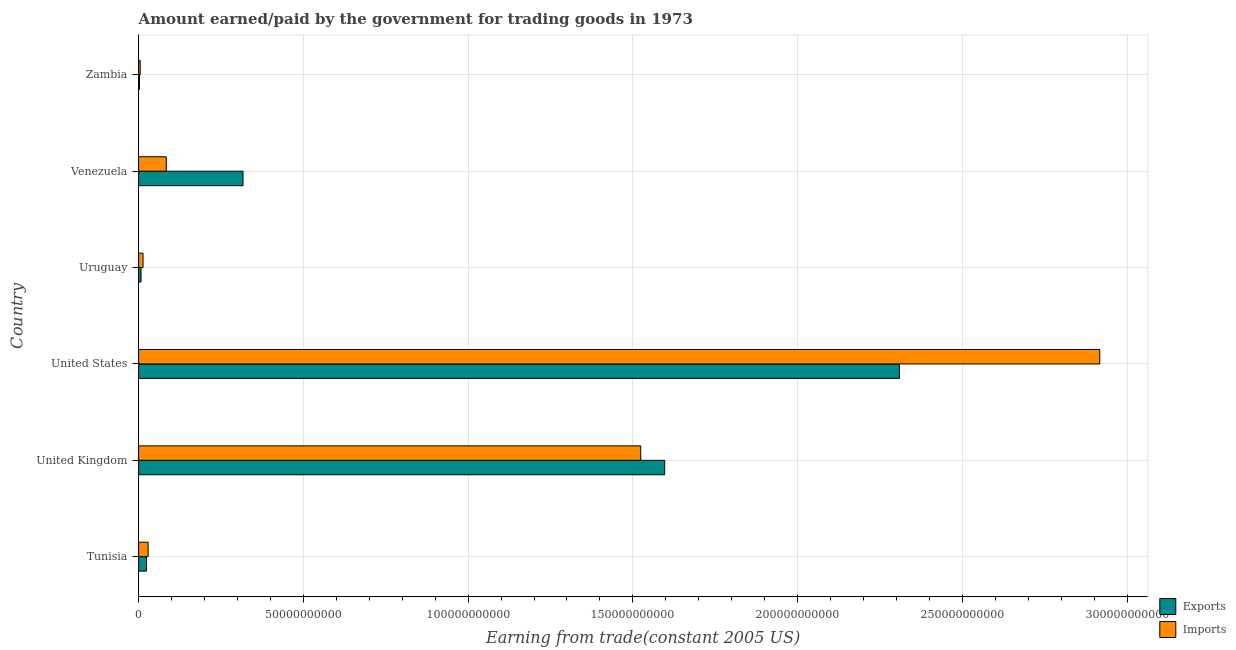Are the number of bars on each tick of the Y-axis equal?
Offer a terse response. Yes. What is the label of the 5th group of bars from the top?
Provide a succinct answer. United Kingdom. In how many cases, is the number of bars for a given country not equal to the number of legend labels?
Keep it short and to the point. 0. What is the amount paid for imports in United States?
Your response must be concise. 2.92e+11. Across all countries, what is the maximum amount earned from exports?
Your answer should be compact. 2.31e+11. Across all countries, what is the minimum amount paid for imports?
Your answer should be very brief. 4.80e+08. In which country was the amount earned from exports maximum?
Offer a very short reply. United States. In which country was the amount earned from exports minimum?
Offer a very short reply. Zambia. What is the total amount paid for imports in the graph?
Your answer should be compact. 4.57e+11. What is the difference between the amount earned from exports in United States and that in Zambia?
Offer a terse response. 2.31e+11. What is the difference between the amount paid for imports in Uruguay and the amount earned from exports in Venezuela?
Your answer should be very brief. -3.03e+1. What is the average amount paid for imports per country?
Make the answer very short. 7.62e+1. What is the difference between the amount earned from exports and amount paid for imports in United States?
Ensure brevity in your answer.  -6.08e+1. What is the ratio of the amount earned from exports in Tunisia to that in Uruguay?
Provide a succinct answer. 3.25. What is the difference between the highest and the second highest amount paid for imports?
Offer a terse response. 1.39e+11. What is the difference between the highest and the lowest amount earned from exports?
Provide a succinct answer. 2.31e+11. In how many countries, is the amount paid for imports greater than the average amount paid for imports taken over all countries?
Ensure brevity in your answer.  2. What does the 1st bar from the top in Tunisia represents?
Offer a terse response. Imports. What does the 1st bar from the bottom in Zambia represents?
Offer a terse response. Exports. How many bars are there?
Provide a succinct answer. 12. How many countries are there in the graph?
Ensure brevity in your answer.  6. What is the difference between two consecutive major ticks on the X-axis?
Give a very brief answer. 5.00e+1. Are the values on the major ticks of X-axis written in scientific E-notation?
Make the answer very short. No. How many legend labels are there?
Your answer should be compact. 2. What is the title of the graph?
Provide a short and direct response. Amount earned/paid by the government for trading goods in 1973. Does "Female population" appear as one of the legend labels in the graph?
Ensure brevity in your answer.  No. What is the label or title of the X-axis?
Your answer should be very brief. Earning from trade(constant 2005 US). What is the label or title of the Y-axis?
Keep it short and to the point. Country. What is the Earning from trade(constant 2005 US) of Exports in Tunisia?
Ensure brevity in your answer.  2.40e+09. What is the Earning from trade(constant 2005 US) of Imports in Tunisia?
Give a very brief answer. 2.89e+09. What is the Earning from trade(constant 2005 US) of Exports in United Kingdom?
Ensure brevity in your answer.  1.60e+11. What is the Earning from trade(constant 2005 US) in Imports in United Kingdom?
Offer a terse response. 1.52e+11. What is the Earning from trade(constant 2005 US) in Exports in United States?
Offer a terse response. 2.31e+11. What is the Earning from trade(constant 2005 US) of Imports in United States?
Your answer should be compact. 2.92e+11. What is the Earning from trade(constant 2005 US) in Exports in Uruguay?
Offer a very short reply. 7.36e+08. What is the Earning from trade(constant 2005 US) of Imports in Uruguay?
Provide a short and direct response. 1.34e+09. What is the Earning from trade(constant 2005 US) of Exports in Venezuela?
Offer a terse response. 3.17e+1. What is the Earning from trade(constant 2005 US) in Imports in Venezuela?
Keep it short and to the point. 8.39e+09. What is the Earning from trade(constant 2005 US) in Exports in Zambia?
Your answer should be compact. 2.44e+08. What is the Earning from trade(constant 2005 US) of Imports in Zambia?
Provide a short and direct response. 4.80e+08. Across all countries, what is the maximum Earning from trade(constant 2005 US) of Exports?
Give a very brief answer. 2.31e+11. Across all countries, what is the maximum Earning from trade(constant 2005 US) of Imports?
Provide a short and direct response. 2.92e+11. Across all countries, what is the minimum Earning from trade(constant 2005 US) of Exports?
Your answer should be compact. 2.44e+08. Across all countries, what is the minimum Earning from trade(constant 2005 US) of Imports?
Offer a very short reply. 4.80e+08. What is the total Earning from trade(constant 2005 US) of Exports in the graph?
Make the answer very short. 4.26e+11. What is the total Earning from trade(constant 2005 US) of Imports in the graph?
Provide a succinct answer. 4.57e+11. What is the difference between the Earning from trade(constant 2005 US) of Exports in Tunisia and that in United Kingdom?
Your response must be concise. -1.57e+11. What is the difference between the Earning from trade(constant 2005 US) in Imports in Tunisia and that in United Kingdom?
Your answer should be compact. -1.49e+11. What is the difference between the Earning from trade(constant 2005 US) in Exports in Tunisia and that in United States?
Your response must be concise. -2.29e+11. What is the difference between the Earning from trade(constant 2005 US) of Imports in Tunisia and that in United States?
Your answer should be compact. -2.89e+11. What is the difference between the Earning from trade(constant 2005 US) of Exports in Tunisia and that in Uruguay?
Ensure brevity in your answer.  1.66e+09. What is the difference between the Earning from trade(constant 2005 US) in Imports in Tunisia and that in Uruguay?
Your response must be concise. 1.55e+09. What is the difference between the Earning from trade(constant 2005 US) in Exports in Tunisia and that in Venezuela?
Offer a very short reply. -2.93e+1. What is the difference between the Earning from trade(constant 2005 US) of Imports in Tunisia and that in Venezuela?
Provide a short and direct response. -5.50e+09. What is the difference between the Earning from trade(constant 2005 US) in Exports in Tunisia and that in Zambia?
Ensure brevity in your answer.  2.15e+09. What is the difference between the Earning from trade(constant 2005 US) in Imports in Tunisia and that in Zambia?
Your answer should be compact. 2.41e+09. What is the difference between the Earning from trade(constant 2005 US) in Exports in United Kingdom and that in United States?
Your response must be concise. -7.12e+1. What is the difference between the Earning from trade(constant 2005 US) of Imports in United Kingdom and that in United States?
Ensure brevity in your answer.  -1.39e+11. What is the difference between the Earning from trade(constant 2005 US) of Exports in United Kingdom and that in Uruguay?
Your response must be concise. 1.59e+11. What is the difference between the Earning from trade(constant 2005 US) of Imports in United Kingdom and that in Uruguay?
Offer a terse response. 1.51e+11. What is the difference between the Earning from trade(constant 2005 US) in Exports in United Kingdom and that in Venezuela?
Make the answer very short. 1.28e+11. What is the difference between the Earning from trade(constant 2005 US) of Imports in United Kingdom and that in Venezuela?
Your response must be concise. 1.44e+11. What is the difference between the Earning from trade(constant 2005 US) of Exports in United Kingdom and that in Zambia?
Your response must be concise. 1.59e+11. What is the difference between the Earning from trade(constant 2005 US) in Imports in United Kingdom and that in Zambia?
Make the answer very short. 1.52e+11. What is the difference between the Earning from trade(constant 2005 US) of Exports in United States and that in Uruguay?
Ensure brevity in your answer.  2.30e+11. What is the difference between the Earning from trade(constant 2005 US) in Imports in United States and that in Uruguay?
Your answer should be compact. 2.90e+11. What is the difference between the Earning from trade(constant 2005 US) of Exports in United States and that in Venezuela?
Make the answer very short. 1.99e+11. What is the difference between the Earning from trade(constant 2005 US) of Imports in United States and that in Venezuela?
Your response must be concise. 2.83e+11. What is the difference between the Earning from trade(constant 2005 US) of Exports in United States and that in Zambia?
Keep it short and to the point. 2.31e+11. What is the difference between the Earning from trade(constant 2005 US) in Imports in United States and that in Zambia?
Your response must be concise. 2.91e+11. What is the difference between the Earning from trade(constant 2005 US) of Exports in Uruguay and that in Venezuela?
Your response must be concise. -3.10e+1. What is the difference between the Earning from trade(constant 2005 US) of Imports in Uruguay and that in Venezuela?
Your answer should be compact. -7.05e+09. What is the difference between the Earning from trade(constant 2005 US) of Exports in Uruguay and that in Zambia?
Provide a short and direct response. 4.93e+08. What is the difference between the Earning from trade(constant 2005 US) of Imports in Uruguay and that in Zambia?
Provide a succinct answer. 8.60e+08. What is the difference between the Earning from trade(constant 2005 US) of Exports in Venezuela and that in Zambia?
Ensure brevity in your answer.  3.14e+1. What is the difference between the Earning from trade(constant 2005 US) in Imports in Venezuela and that in Zambia?
Your response must be concise. 7.91e+09. What is the difference between the Earning from trade(constant 2005 US) of Exports in Tunisia and the Earning from trade(constant 2005 US) of Imports in United Kingdom?
Offer a very short reply. -1.50e+11. What is the difference between the Earning from trade(constant 2005 US) of Exports in Tunisia and the Earning from trade(constant 2005 US) of Imports in United States?
Offer a terse response. -2.89e+11. What is the difference between the Earning from trade(constant 2005 US) in Exports in Tunisia and the Earning from trade(constant 2005 US) in Imports in Uruguay?
Your answer should be very brief. 1.06e+09. What is the difference between the Earning from trade(constant 2005 US) of Exports in Tunisia and the Earning from trade(constant 2005 US) of Imports in Venezuela?
Offer a very short reply. -6.00e+09. What is the difference between the Earning from trade(constant 2005 US) of Exports in Tunisia and the Earning from trade(constant 2005 US) of Imports in Zambia?
Make the answer very short. 1.92e+09. What is the difference between the Earning from trade(constant 2005 US) in Exports in United Kingdom and the Earning from trade(constant 2005 US) in Imports in United States?
Ensure brevity in your answer.  -1.32e+11. What is the difference between the Earning from trade(constant 2005 US) of Exports in United Kingdom and the Earning from trade(constant 2005 US) of Imports in Uruguay?
Ensure brevity in your answer.  1.58e+11. What is the difference between the Earning from trade(constant 2005 US) in Exports in United Kingdom and the Earning from trade(constant 2005 US) in Imports in Venezuela?
Give a very brief answer. 1.51e+11. What is the difference between the Earning from trade(constant 2005 US) of Exports in United Kingdom and the Earning from trade(constant 2005 US) of Imports in Zambia?
Give a very brief answer. 1.59e+11. What is the difference between the Earning from trade(constant 2005 US) in Exports in United States and the Earning from trade(constant 2005 US) in Imports in Uruguay?
Provide a succinct answer. 2.30e+11. What is the difference between the Earning from trade(constant 2005 US) in Exports in United States and the Earning from trade(constant 2005 US) in Imports in Venezuela?
Give a very brief answer. 2.23e+11. What is the difference between the Earning from trade(constant 2005 US) of Exports in United States and the Earning from trade(constant 2005 US) of Imports in Zambia?
Give a very brief answer. 2.30e+11. What is the difference between the Earning from trade(constant 2005 US) in Exports in Uruguay and the Earning from trade(constant 2005 US) in Imports in Venezuela?
Your answer should be compact. -7.66e+09. What is the difference between the Earning from trade(constant 2005 US) in Exports in Uruguay and the Earning from trade(constant 2005 US) in Imports in Zambia?
Give a very brief answer. 2.56e+08. What is the difference between the Earning from trade(constant 2005 US) of Exports in Venezuela and the Earning from trade(constant 2005 US) of Imports in Zambia?
Your response must be concise. 3.12e+1. What is the average Earning from trade(constant 2005 US) in Exports per country?
Ensure brevity in your answer.  7.09e+1. What is the average Earning from trade(constant 2005 US) in Imports per country?
Give a very brief answer. 7.62e+1. What is the difference between the Earning from trade(constant 2005 US) in Exports and Earning from trade(constant 2005 US) in Imports in Tunisia?
Offer a very short reply. -4.94e+08. What is the difference between the Earning from trade(constant 2005 US) of Exports and Earning from trade(constant 2005 US) of Imports in United Kingdom?
Make the answer very short. 7.27e+09. What is the difference between the Earning from trade(constant 2005 US) in Exports and Earning from trade(constant 2005 US) in Imports in United States?
Keep it short and to the point. -6.08e+1. What is the difference between the Earning from trade(constant 2005 US) in Exports and Earning from trade(constant 2005 US) in Imports in Uruguay?
Your response must be concise. -6.03e+08. What is the difference between the Earning from trade(constant 2005 US) of Exports and Earning from trade(constant 2005 US) of Imports in Venezuela?
Offer a very short reply. 2.33e+1. What is the difference between the Earning from trade(constant 2005 US) of Exports and Earning from trade(constant 2005 US) of Imports in Zambia?
Give a very brief answer. -2.36e+08. What is the ratio of the Earning from trade(constant 2005 US) of Exports in Tunisia to that in United Kingdom?
Give a very brief answer. 0.01. What is the ratio of the Earning from trade(constant 2005 US) of Imports in Tunisia to that in United Kingdom?
Keep it short and to the point. 0.02. What is the ratio of the Earning from trade(constant 2005 US) of Exports in Tunisia to that in United States?
Offer a terse response. 0.01. What is the ratio of the Earning from trade(constant 2005 US) in Imports in Tunisia to that in United States?
Give a very brief answer. 0.01. What is the ratio of the Earning from trade(constant 2005 US) of Exports in Tunisia to that in Uruguay?
Offer a very short reply. 3.25. What is the ratio of the Earning from trade(constant 2005 US) of Imports in Tunisia to that in Uruguay?
Provide a short and direct response. 2.16. What is the ratio of the Earning from trade(constant 2005 US) of Exports in Tunisia to that in Venezuela?
Keep it short and to the point. 0.08. What is the ratio of the Earning from trade(constant 2005 US) in Imports in Tunisia to that in Venezuela?
Your answer should be very brief. 0.34. What is the ratio of the Earning from trade(constant 2005 US) in Exports in Tunisia to that in Zambia?
Your answer should be very brief. 9.84. What is the ratio of the Earning from trade(constant 2005 US) in Imports in Tunisia to that in Zambia?
Provide a succinct answer. 6.02. What is the ratio of the Earning from trade(constant 2005 US) in Exports in United Kingdom to that in United States?
Give a very brief answer. 0.69. What is the ratio of the Earning from trade(constant 2005 US) of Imports in United Kingdom to that in United States?
Provide a succinct answer. 0.52. What is the ratio of the Earning from trade(constant 2005 US) in Exports in United Kingdom to that in Uruguay?
Provide a succinct answer. 216.87. What is the ratio of the Earning from trade(constant 2005 US) in Imports in United Kingdom to that in Uruguay?
Make the answer very short. 113.75. What is the ratio of the Earning from trade(constant 2005 US) in Exports in United Kingdom to that in Venezuela?
Provide a succinct answer. 5.04. What is the ratio of the Earning from trade(constant 2005 US) of Imports in United Kingdom to that in Venezuela?
Keep it short and to the point. 18.16. What is the ratio of the Earning from trade(constant 2005 US) in Exports in United Kingdom to that in Zambia?
Provide a succinct answer. 655.49. What is the ratio of the Earning from trade(constant 2005 US) in Imports in United Kingdom to that in Zambia?
Ensure brevity in your answer.  317.45. What is the ratio of the Earning from trade(constant 2005 US) of Exports in United States to that in Uruguay?
Give a very brief answer. 313.66. What is the ratio of the Earning from trade(constant 2005 US) in Imports in United States to that in Uruguay?
Give a very brief answer. 217.74. What is the ratio of the Earning from trade(constant 2005 US) in Exports in United States to that in Venezuela?
Make the answer very short. 7.29. What is the ratio of the Earning from trade(constant 2005 US) of Imports in United States to that in Venezuela?
Offer a very short reply. 34.76. What is the ratio of the Earning from trade(constant 2005 US) of Exports in United States to that in Zambia?
Ensure brevity in your answer.  948.02. What is the ratio of the Earning from trade(constant 2005 US) of Imports in United States to that in Zambia?
Offer a very short reply. 607.65. What is the ratio of the Earning from trade(constant 2005 US) in Exports in Uruguay to that in Venezuela?
Your answer should be compact. 0.02. What is the ratio of the Earning from trade(constant 2005 US) of Imports in Uruguay to that in Venezuela?
Provide a succinct answer. 0.16. What is the ratio of the Earning from trade(constant 2005 US) of Exports in Uruguay to that in Zambia?
Your response must be concise. 3.02. What is the ratio of the Earning from trade(constant 2005 US) in Imports in Uruguay to that in Zambia?
Keep it short and to the point. 2.79. What is the ratio of the Earning from trade(constant 2005 US) in Exports in Venezuela to that in Zambia?
Ensure brevity in your answer.  130.1. What is the ratio of the Earning from trade(constant 2005 US) in Imports in Venezuela to that in Zambia?
Give a very brief answer. 17.48. What is the difference between the highest and the second highest Earning from trade(constant 2005 US) of Exports?
Offer a very short reply. 7.12e+1. What is the difference between the highest and the second highest Earning from trade(constant 2005 US) in Imports?
Make the answer very short. 1.39e+11. What is the difference between the highest and the lowest Earning from trade(constant 2005 US) in Exports?
Provide a succinct answer. 2.31e+11. What is the difference between the highest and the lowest Earning from trade(constant 2005 US) of Imports?
Keep it short and to the point. 2.91e+11. 